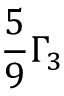<formula> <loc_0><loc_0><loc_500><loc_500>\frac { 5 } { 9 } \Gamma _ { 3 }</formula> 